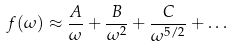<formula> <loc_0><loc_0><loc_500><loc_500>f ( \omega ) \approx \frac { A } { \omega } + \frac { B } { \omega ^ { 2 } } + \frac { C } { \omega ^ { 5 / 2 } } + \dots</formula> 